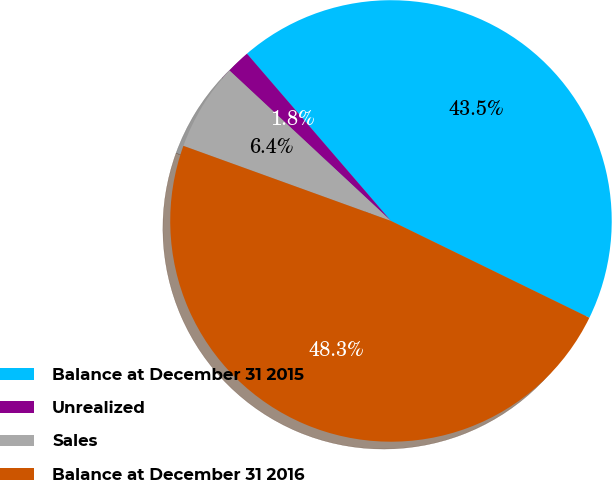Convert chart to OTSL. <chart><loc_0><loc_0><loc_500><loc_500><pie_chart><fcel>Balance at December 31 2015<fcel>Unrealized<fcel>Sales<fcel>Balance at December 31 2016<nl><fcel>43.54%<fcel>1.75%<fcel>6.41%<fcel>48.3%<nl></chart> 